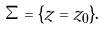Convert formula to latex. <formula><loc_0><loc_0><loc_500><loc_500>\Sigma = \{ z = z _ { 0 } \} .</formula> 